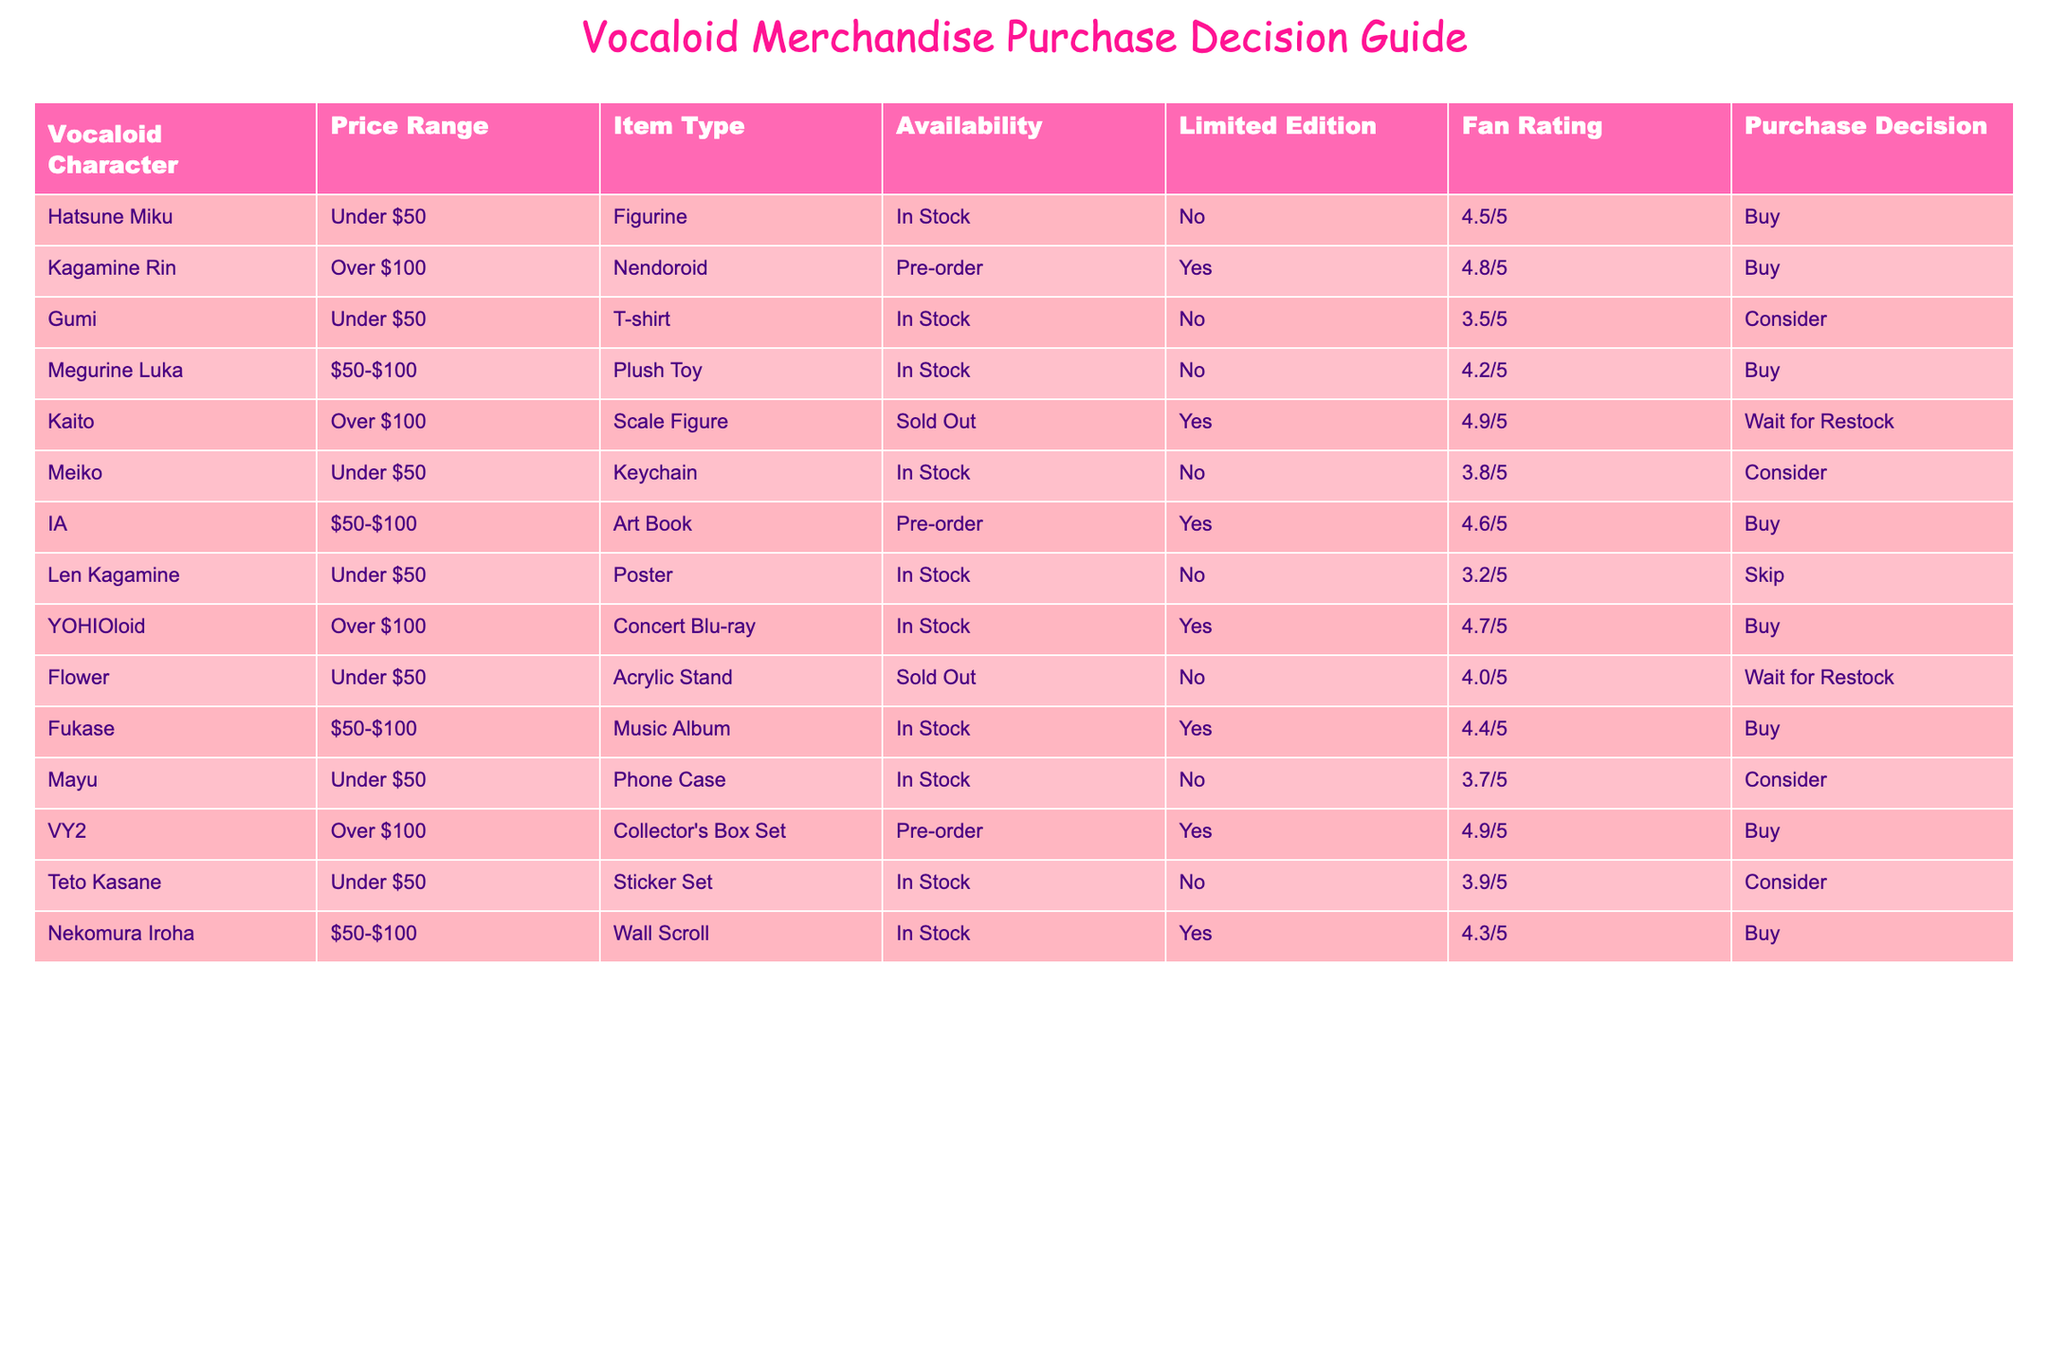What is the average fan rating for items that are in stock? To find the average fan rating for items that are in stock, we first identify all the items with "In Stock" in the Availability column. The ratings for these items are: 4.5, 4.2, 4.6, 3.5, 3.8, 4.4, 3.9, and 4.3. We sum these ratings: 4.5 + 4.2 + 4.6 + 3.5 + 3.8 + 4.4 + 3.9 + 4.3 = 33.2. There are 8 items in total, so the average is 33.2 / 8 = 4.15.
Answer: 4.15 Which Vocaloid merchandise has the highest fan rating? To determine which item has the highest fan rating, we look at the Fan Rating column. The highest rating in the table is 4.9, which belongs to both Kaito and VY2.
Answer: Kaito and VY2 Is there any merchandise from the table that is a limited edition and still has stock available? We check the Limited Edition column and Availability column. None of the items that are "In Stock" have a "Yes" in the Limited Edition column, indicating that there are no items available for purchase that are both limited edition and currently in stock.
Answer: No How many items are available for pre-order with a fan rating above 4.5? We filter the items that are for pre-order from the Availability column and check their fan ratings. The items are Kagamine Rin (4.8) and IA (4.6). Thus, there are 2 items that meet these criteria.
Answer: 2 What percentage of the merchandise is priced over $100 and has a purchase decision to "Buy"? First, we identify items priced over $100. There are 4 in total: Kagamine Rin, Kaito, YOHIOloid, and VY2. Among these, only YOHIOloid and VY2 have a purchase decision of "Buy". We calculate the percentage: (2 / 4) * 100 = 50%.
Answer: 50% 